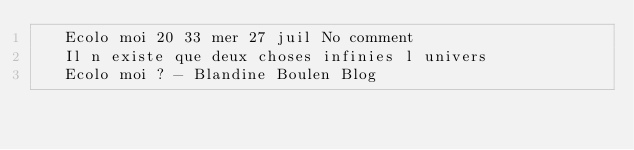Convert code to text. <code><loc_0><loc_0><loc_500><loc_500><_XML_>	 Ecolo moi 20 33 mer 27 juil No comment 
	 Il n existe que deux choses infinies l univers 
	 Ecolo moi ? - Blandine Boulen Blog 
	  
</code> 